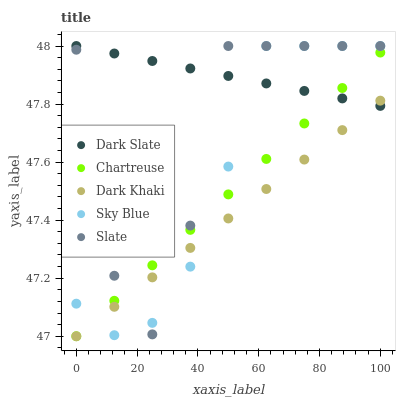Does Dark Khaki have the minimum area under the curve?
Answer yes or no. Yes. Does Dark Slate have the maximum area under the curve?
Answer yes or no. Yes. Does Chartreuse have the minimum area under the curve?
Answer yes or no. No. Does Chartreuse have the maximum area under the curve?
Answer yes or no. No. Is Dark Khaki the smoothest?
Answer yes or no. Yes. Is Slate the roughest?
Answer yes or no. Yes. Is Dark Slate the smoothest?
Answer yes or no. No. Is Dark Slate the roughest?
Answer yes or no. No. Does Dark Khaki have the lowest value?
Answer yes or no. Yes. Does Dark Slate have the lowest value?
Answer yes or no. No. Does Sky Blue have the highest value?
Answer yes or no. Yes. Does Chartreuse have the highest value?
Answer yes or no. No. Does Sky Blue intersect Chartreuse?
Answer yes or no. Yes. Is Sky Blue less than Chartreuse?
Answer yes or no. No. Is Sky Blue greater than Chartreuse?
Answer yes or no. No. 